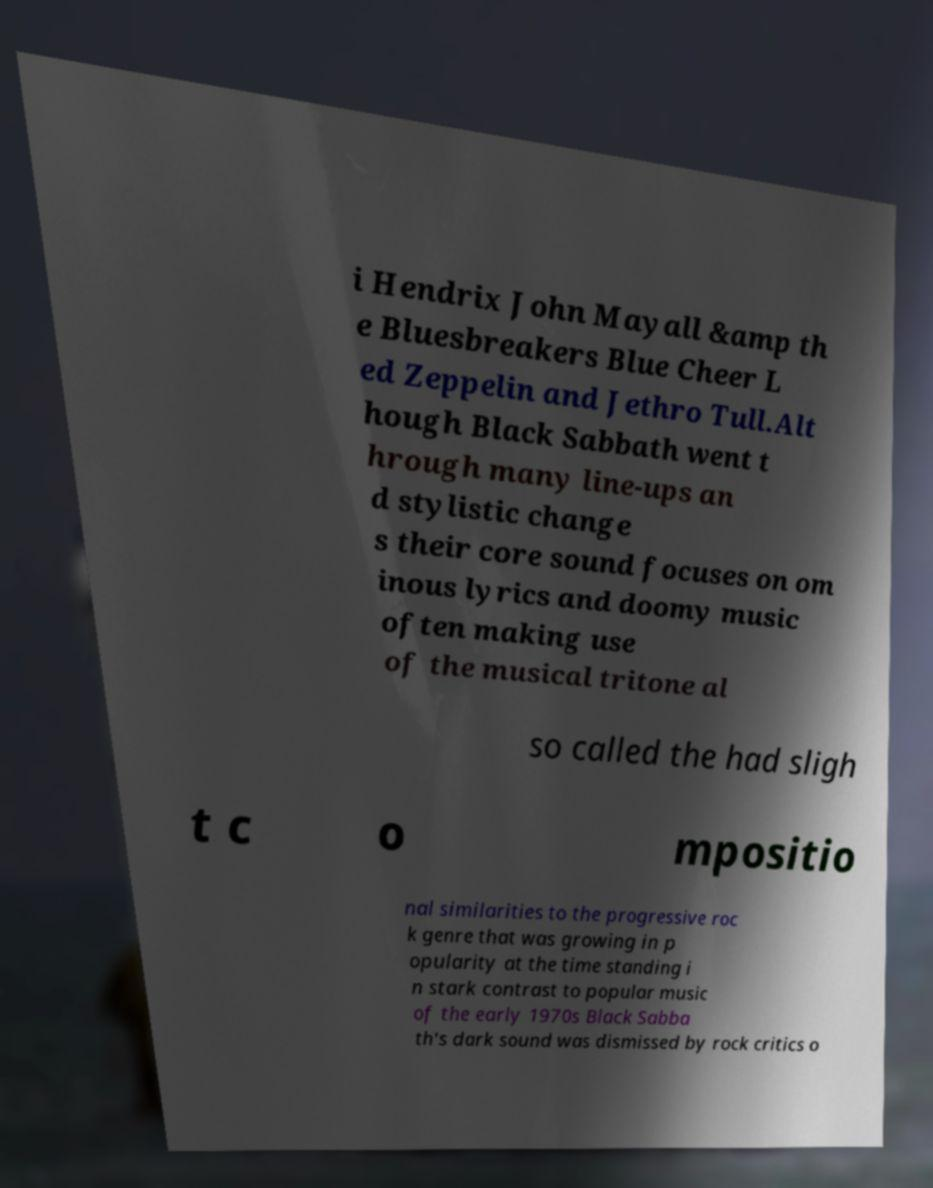Could you assist in decoding the text presented in this image and type it out clearly? i Hendrix John Mayall &amp th e Bluesbreakers Blue Cheer L ed Zeppelin and Jethro Tull.Alt hough Black Sabbath went t hrough many line-ups an d stylistic change s their core sound focuses on om inous lyrics and doomy music often making use of the musical tritone al so called the had sligh t c o mpositio nal similarities to the progressive roc k genre that was growing in p opularity at the time standing i n stark contrast to popular music of the early 1970s Black Sabba th's dark sound was dismissed by rock critics o 